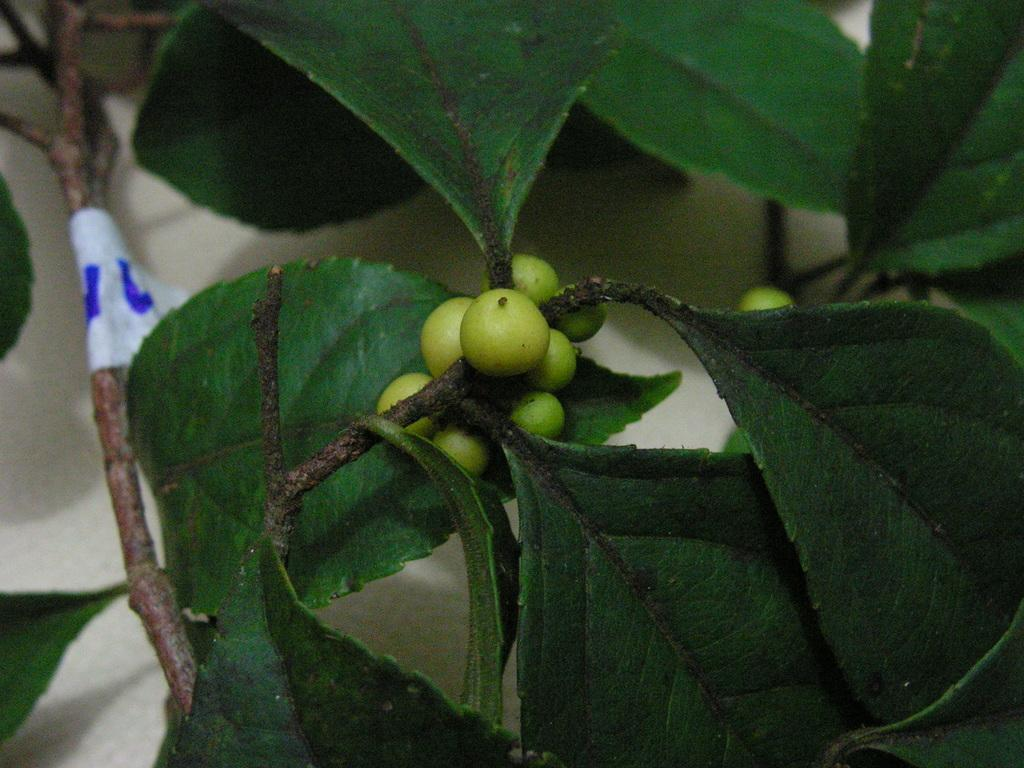What type of vegetation can be seen in the image? There are leaves in the image. What is the color of the leaves? The leaves are green in color. What else is present in the image besides leaves? There are fruits in the image. What is the color of the fruits? The fruits are green in color. Where is the crown located in the image? There is no crown present in the image. What type of trucks can be seen in the image? There are no trucks present in the image. 